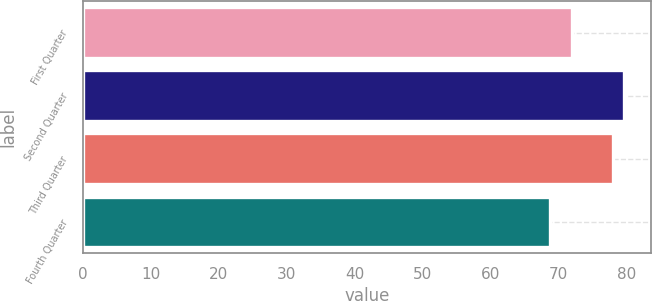<chart> <loc_0><loc_0><loc_500><loc_500><bar_chart><fcel>First Quarter<fcel>Second Quarter<fcel>Third Quarter<fcel>Fourth Quarter<nl><fcel>71.98<fcel>79.63<fcel>77.93<fcel>68.73<nl></chart> 